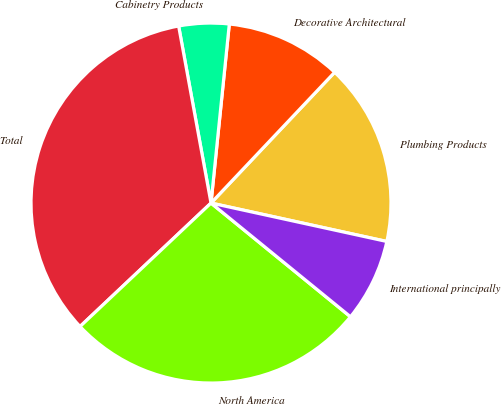Convert chart. <chart><loc_0><loc_0><loc_500><loc_500><pie_chart><fcel>Plumbing Products<fcel>Decorative Architectural<fcel>Cabinetry Products<fcel>Total<fcel>North America<fcel>International principally<nl><fcel>16.37%<fcel>10.43%<fcel>4.5%<fcel>34.15%<fcel>27.08%<fcel>7.46%<nl></chart> 